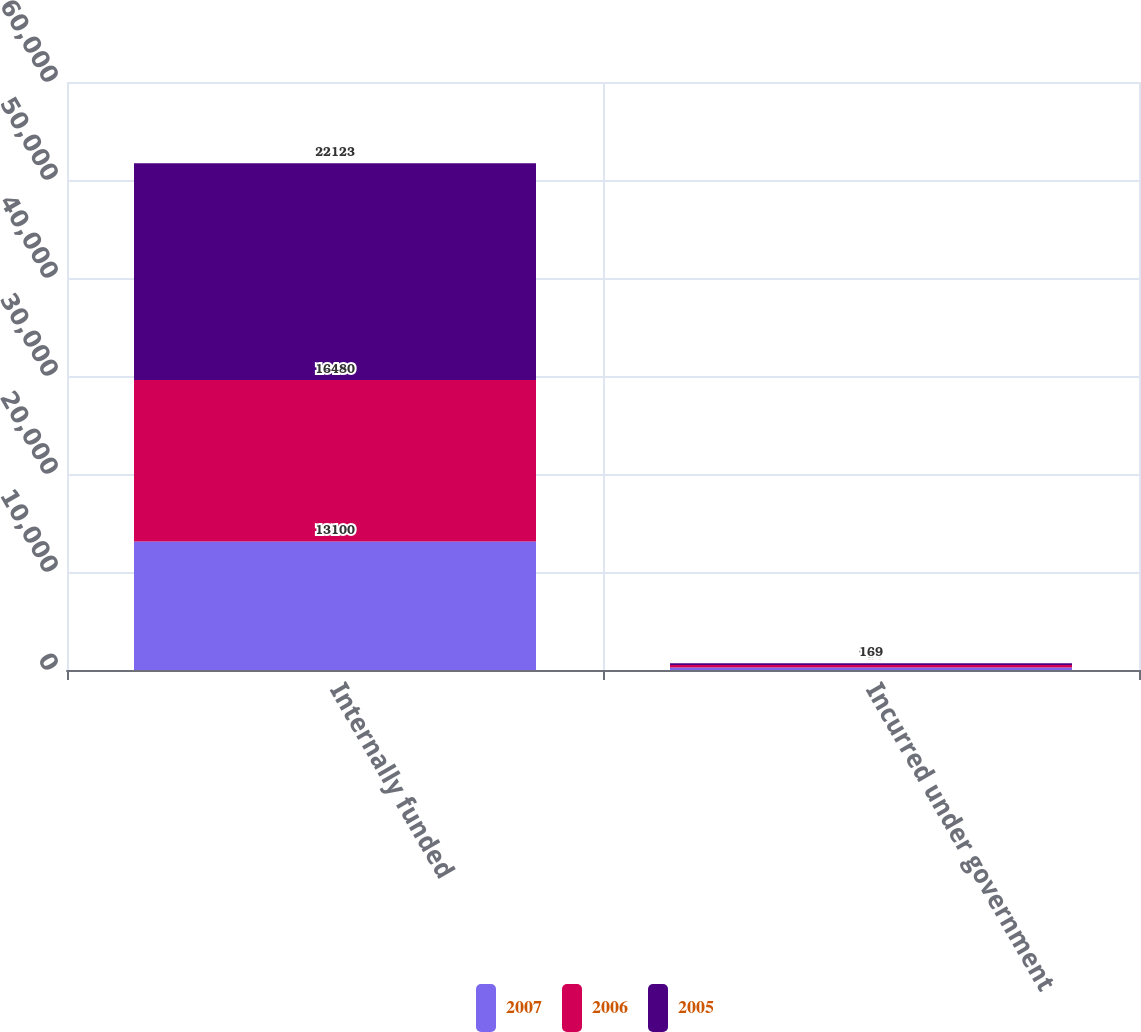Convert chart. <chart><loc_0><loc_0><loc_500><loc_500><stacked_bar_chart><ecel><fcel>Internally funded<fcel>Incurred under government<nl><fcel>2007<fcel>13100<fcel>250<nl><fcel>2006<fcel>16480<fcel>259<nl><fcel>2005<fcel>22123<fcel>169<nl></chart> 